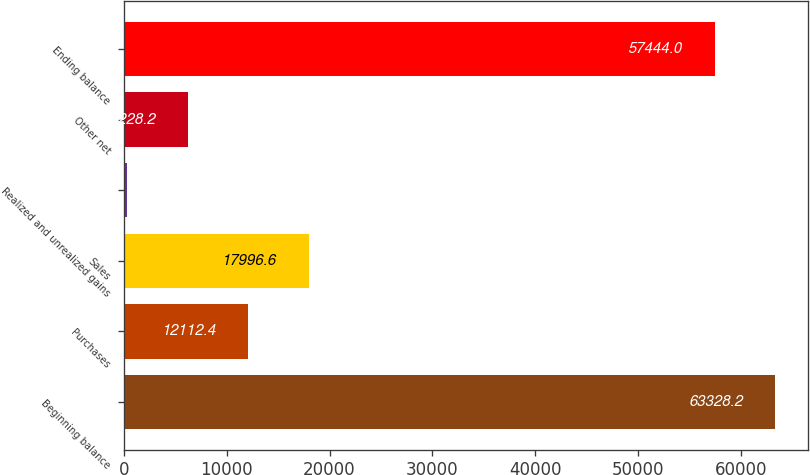Convert chart. <chart><loc_0><loc_0><loc_500><loc_500><bar_chart><fcel>Beginning balance<fcel>Purchases<fcel>Sales<fcel>Realized and unrealized gains<fcel>Other net<fcel>Ending balance<nl><fcel>63328.2<fcel>12112.4<fcel>17996.6<fcel>344<fcel>6228.2<fcel>57444<nl></chart> 